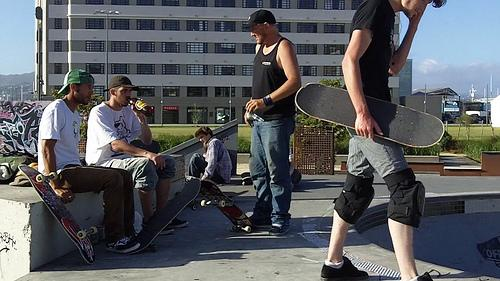What are the noticeable accessories worn by the man in the picture? The man is wearing a black tank top, blue jeans, a wrist band, and a black cap on his head. Please give a brief description of what the main person in the picture is doing. The man is sitting on the stairs, drinking from a bottle, and holding a skateboard in his hand. Express what the main object in the image is, and what is special about it. The main object in the image is a long black skateboard, distinct due to its color and size compared to the colorful one nearby. What elements of the man's attire in the image can be identified? The man is wearing a black baseball cap, black tank top, blue jeans, knee pads, and a wrist band. Mention the primary object in the frame and its key characteristics. A long black skateboard with a colorful skateboard leaning against the wall, both placed on the ground. What is significant about the man's pants? The man is wearing brown pants that stand out against the gray ground and the backdrop of the building. Please provide a concise summary of the main activity taking place in the image. A man holding a skateboard and drinking a beverage is engaged in a conversation with a group of men sitting around him. Describe the environment or setting where the picture was taken. The picture was taken with a gray cement ground and a concrete wall, with tall buildings and trimmed grass in the background. Briefly state what is happening in the image, including the key subject and surrounding elements. In the image, a man sits on stairs drinking a beverage and holding a skateboard, while other men sit nearby and a colorful skateboard leans against the wall. Give a brief description of the scene in the image, including the main subject and their activity. The scene shows a group of men sitting on the ground, with one man in focus drinking from a bottle and holding a skateboard. 